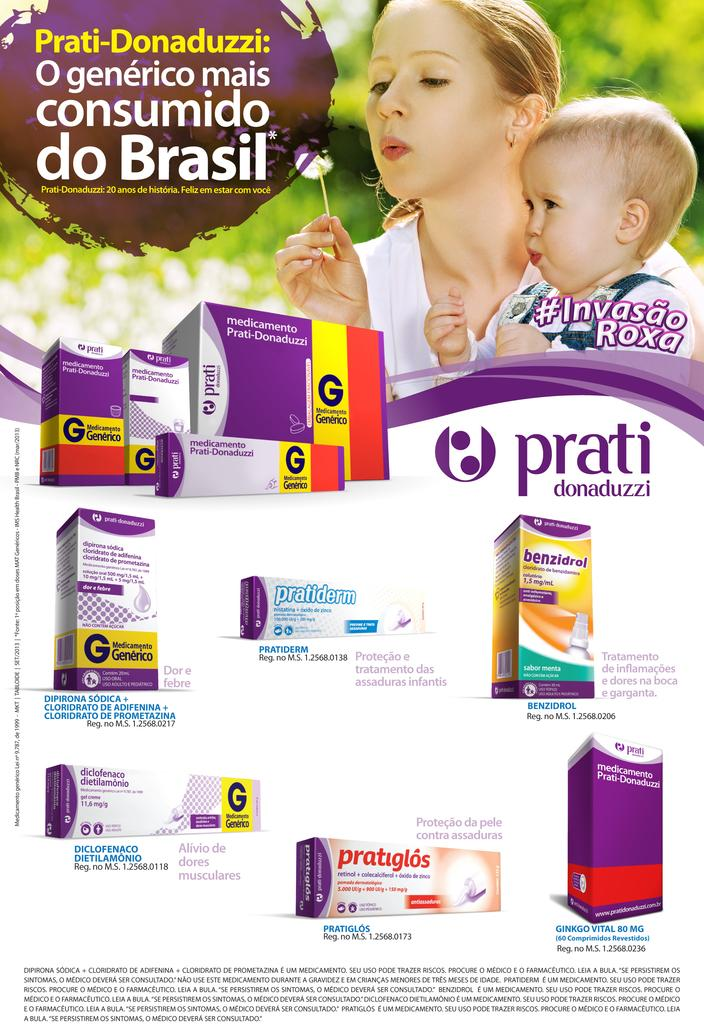<image>
Write a terse but informative summary of the picture. A woman and baby in an advertisement in Spanish advertising prati donaduzzi 